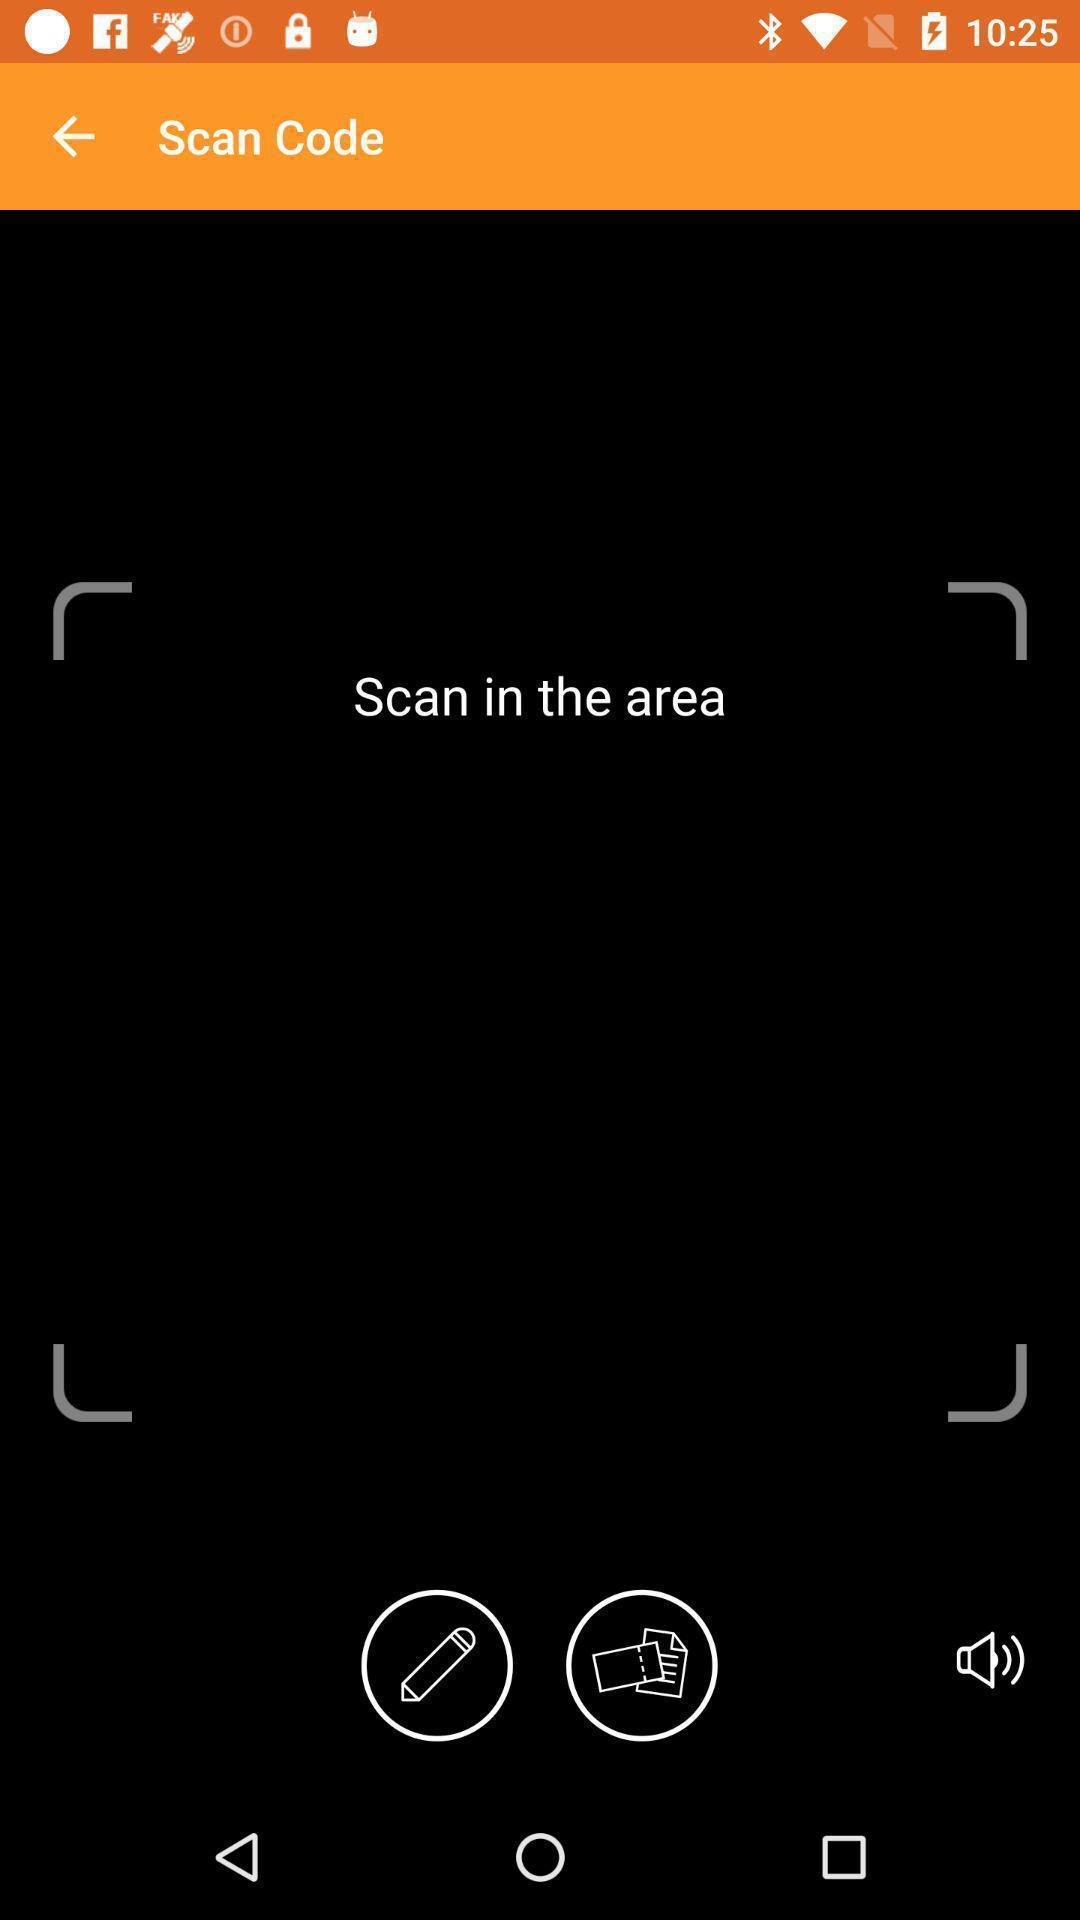What details can you identify in this image? Window displaying a scanning page. 